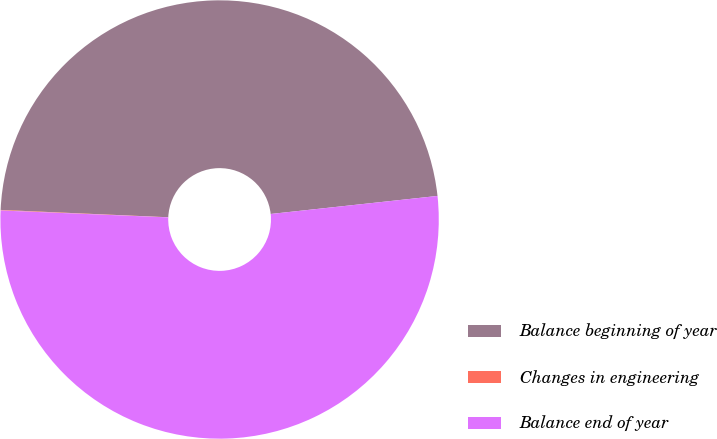<chart> <loc_0><loc_0><loc_500><loc_500><pie_chart><fcel>Balance beginning of year<fcel>Changes in engineering<fcel>Balance end of year<nl><fcel>47.59%<fcel>0.04%<fcel>52.37%<nl></chart> 